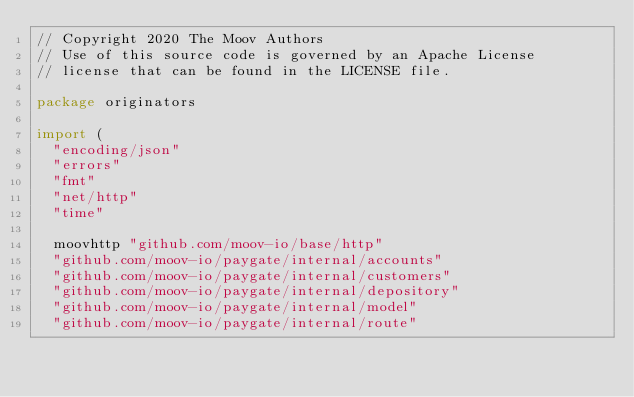<code> <loc_0><loc_0><loc_500><loc_500><_Go_>// Copyright 2020 The Moov Authors
// Use of this source code is governed by an Apache License
// license that can be found in the LICENSE file.

package originators

import (
	"encoding/json"
	"errors"
	"fmt"
	"net/http"
	"time"

	moovhttp "github.com/moov-io/base/http"
	"github.com/moov-io/paygate/internal/accounts"
	"github.com/moov-io/paygate/internal/customers"
	"github.com/moov-io/paygate/internal/depository"
	"github.com/moov-io/paygate/internal/model"
	"github.com/moov-io/paygate/internal/route"</code> 